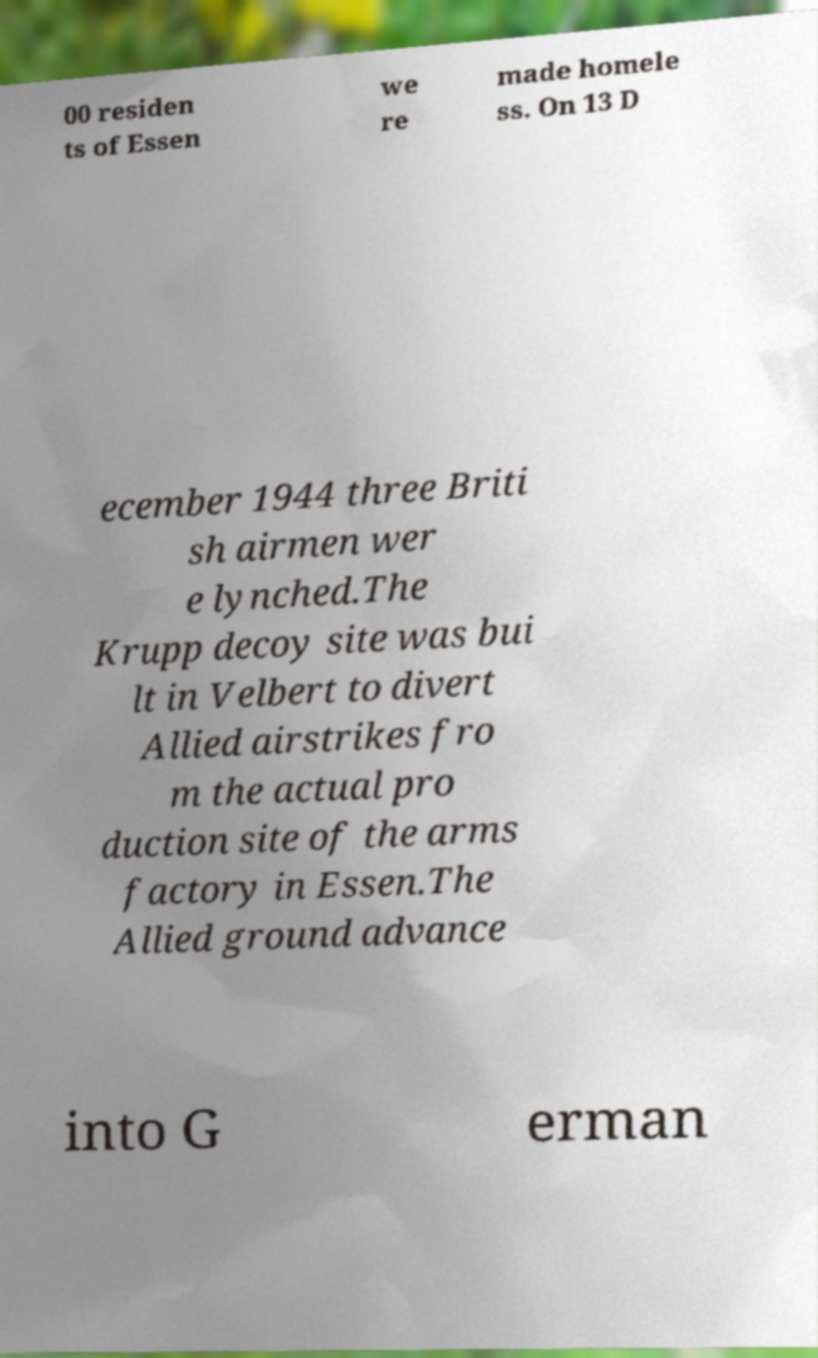Can you accurately transcribe the text from the provided image for me? 00 residen ts of Essen we re made homele ss. On 13 D ecember 1944 three Briti sh airmen wer e lynched.The Krupp decoy site was bui lt in Velbert to divert Allied airstrikes fro m the actual pro duction site of the arms factory in Essen.The Allied ground advance into G erman 